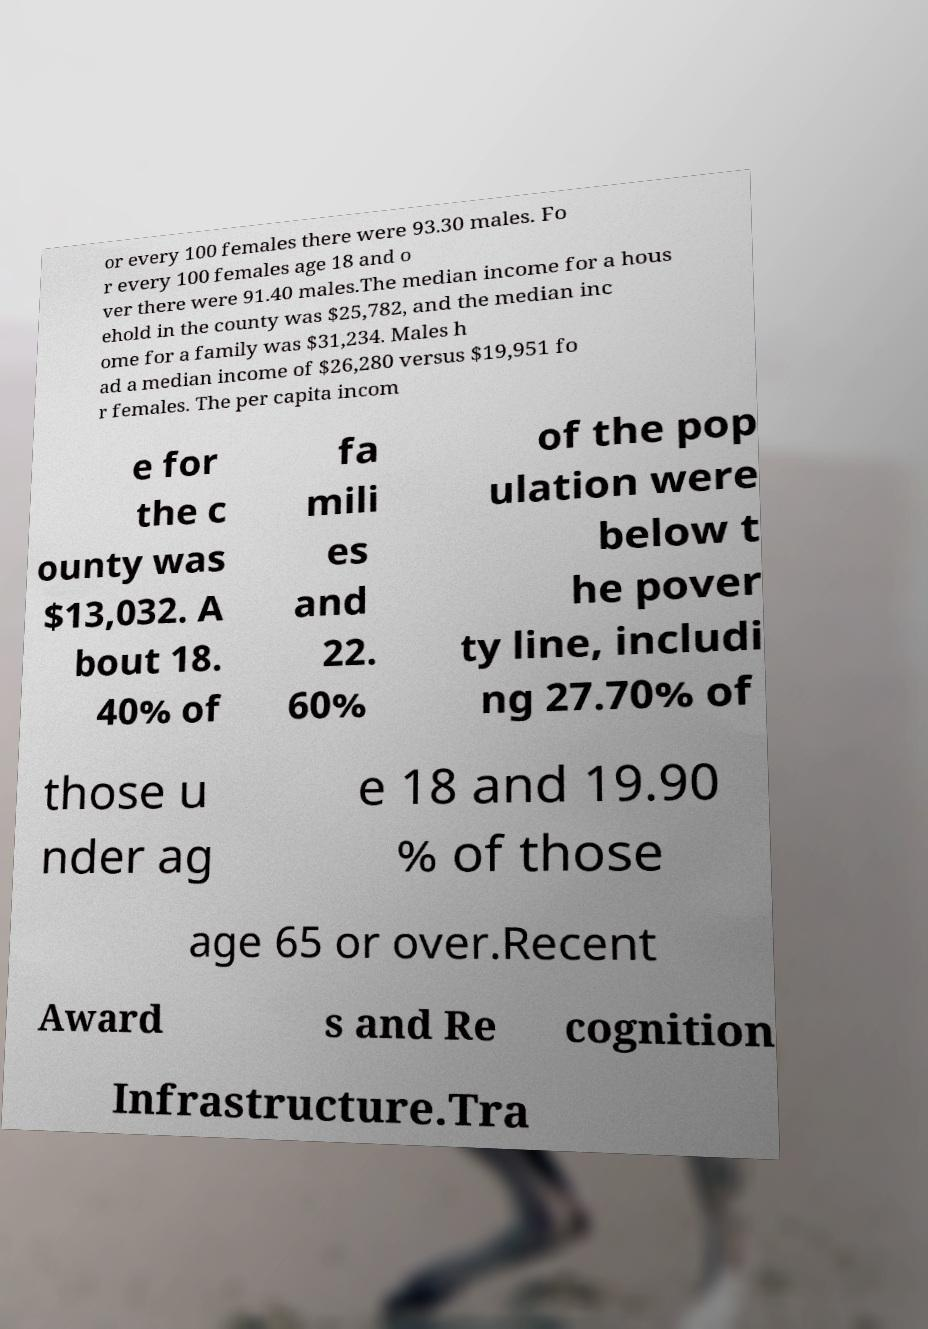Please read and relay the text visible in this image. What does it say? or every 100 females there were 93.30 males. Fo r every 100 females age 18 and o ver there were 91.40 males.The median income for a hous ehold in the county was $25,782, and the median inc ome for a family was $31,234. Males h ad a median income of $26,280 versus $19,951 fo r females. The per capita incom e for the c ounty was $13,032. A bout 18. 40% of fa mili es and 22. 60% of the pop ulation were below t he pover ty line, includi ng 27.70% of those u nder ag e 18 and 19.90 % of those age 65 or over.Recent Award s and Re cognition Infrastructure.Tra 